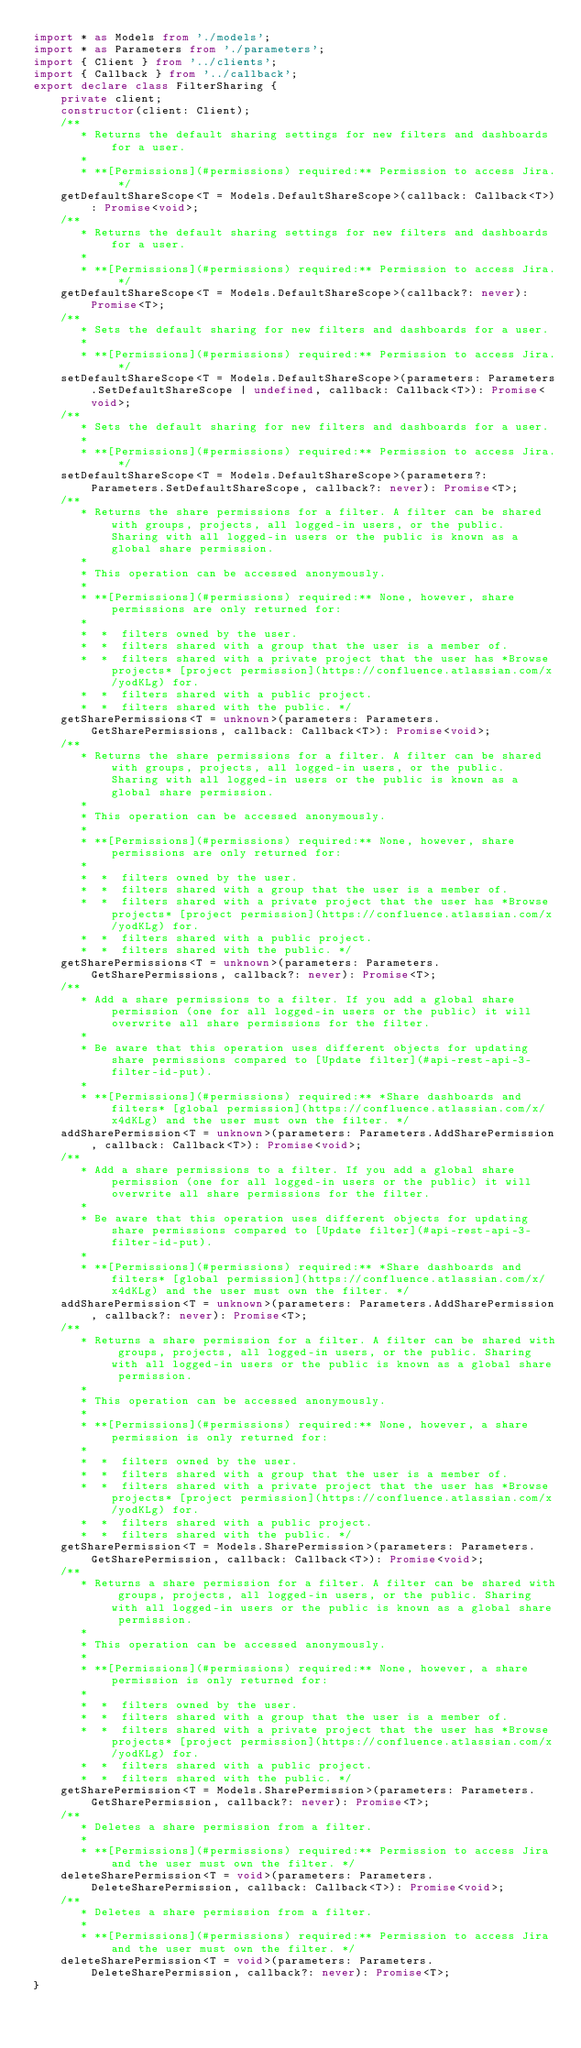<code> <loc_0><loc_0><loc_500><loc_500><_TypeScript_>import * as Models from './models';
import * as Parameters from './parameters';
import { Client } from '../clients';
import { Callback } from '../callback';
export declare class FilterSharing {
    private client;
    constructor(client: Client);
    /**
       * Returns the default sharing settings for new filters and dashboards for a user.
       *
       * **[Permissions](#permissions) required:** Permission to access Jira. */
    getDefaultShareScope<T = Models.DefaultShareScope>(callback: Callback<T>): Promise<void>;
    /**
       * Returns the default sharing settings for new filters and dashboards for a user.
       *
       * **[Permissions](#permissions) required:** Permission to access Jira. */
    getDefaultShareScope<T = Models.DefaultShareScope>(callback?: never): Promise<T>;
    /**
       * Sets the default sharing for new filters and dashboards for a user.
       *
       * **[Permissions](#permissions) required:** Permission to access Jira. */
    setDefaultShareScope<T = Models.DefaultShareScope>(parameters: Parameters.SetDefaultShareScope | undefined, callback: Callback<T>): Promise<void>;
    /**
       * Sets the default sharing for new filters and dashboards for a user.
       *
       * **[Permissions](#permissions) required:** Permission to access Jira. */
    setDefaultShareScope<T = Models.DefaultShareScope>(parameters?: Parameters.SetDefaultShareScope, callback?: never): Promise<T>;
    /**
       * Returns the share permissions for a filter. A filter can be shared with groups, projects, all logged-in users, or the public. Sharing with all logged-in users or the public is known as a global share permission.
       *
       * This operation can be accessed anonymously.
       *
       * **[Permissions](#permissions) required:** None, however, share permissions are only returned for:
       *
       *  *  filters owned by the user.
       *  *  filters shared with a group that the user is a member of.
       *  *  filters shared with a private project that the user has *Browse projects* [project permission](https://confluence.atlassian.com/x/yodKLg) for.
       *  *  filters shared with a public project.
       *  *  filters shared with the public. */
    getSharePermissions<T = unknown>(parameters: Parameters.GetSharePermissions, callback: Callback<T>): Promise<void>;
    /**
       * Returns the share permissions for a filter. A filter can be shared with groups, projects, all logged-in users, or the public. Sharing with all logged-in users or the public is known as a global share permission.
       *
       * This operation can be accessed anonymously.
       *
       * **[Permissions](#permissions) required:** None, however, share permissions are only returned for:
       *
       *  *  filters owned by the user.
       *  *  filters shared with a group that the user is a member of.
       *  *  filters shared with a private project that the user has *Browse projects* [project permission](https://confluence.atlassian.com/x/yodKLg) for.
       *  *  filters shared with a public project.
       *  *  filters shared with the public. */
    getSharePermissions<T = unknown>(parameters: Parameters.GetSharePermissions, callback?: never): Promise<T>;
    /**
       * Add a share permissions to a filter. If you add a global share permission (one for all logged-in users or the public) it will overwrite all share permissions for the filter.
       *
       * Be aware that this operation uses different objects for updating share permissions compared to [Update filter](#api-rest-api-3-filter-id-put).
       *
       * **[Permissions](#permissions) required:** *Share dashboards and filters* [global permission](https://confluence.atlassian.com/x/x4dKLg) and the user must own the filter. */
    addSharePermission<T = unknown>(parameters: Parameters.AddSharePermission, callback: Callback<T>): Promise<void>;
    /**
       * Add a share permissions to a filter. If you add a global share permission (one for all logged-in users or the public) it will overwrite all share permissions for the filter.
       *
       * Be aware that this operation uses different objects for updating share permissions compared to [Update filter](#api-rest-api-3-filter-id-put).
       *
       * **[Permissions](#permissions) required:** *Share dashboards and filters* [global permission](https://confluence.atlassian.com/x/x4dKLg) and the user must own the filter. */
    addSharePermission<T = unknown>(parameters: Parameters.AddSharePermission, callback?: never): Promise<T>;
    /**
       * Returns a share permission for a filter. A filter can be shared with groups, projects, all logged-in users, or the public. Sharing with all logged-in users or the public is known as a global share permission.
       *
       * This operation can be accessed anonymously.
       *
       * **[Permissions](#permissions) required:** None, however, a share permission is only returned for:
       *
       *  *  filters owned by the user.
       *  *  filters shared with a group that the user is a member of.
       *  *  filters shared with a private project that the user has *Browse projects* [project permission](https://confluence.atlassian.com/x/yodKLg) for.
       *  *  filters shared with a public project.
       *  *  filters shared with the public. */
    getSharePermission<T = Models.SharePermission>(parameters: Parameters.GetSharePermission, callback: Callback<T>): Promise<void>;
    /**
       * Returns a share permission for a filter. A filter can be shared with groups, projects, all logged-in users, or the public. Sharing with all logged-in users or the public is known as a global share permission.
       *
       * This operation can be accessed anonymously.
       *
       * **[Permissions](#permissions) required:** None, however, a share permission is only returned for:
       *
       *  *  filters owned by the user.
       *  *  filters shared with a group that the user is a member of.
       *  *  filters shared with a private project that the user has *Browse projects* [project permission](https://confluence.atlassian.com/x/yodKLg) for.
       *  *  filters shared with a public project.
       *  *  filters shared with the public. */
    getSharePermission<T = Models.SharePermission>(parameters: Parameters.GetSharePermission, callback?: never): Promise<T>;
    /**
       * Deletes a share permission from a filter.
       *
       * **[Permissions](#permissions) required:** Permission to access Jira and the user must own the filter. */
    deleteSharePermission<T = void>(parameters: Parameters.DeleteSharePermission, callback: Callback<T>): Promise<void>;
    /**
       * Deletes a share permission from a filter.
       *
       * **[Permissions](#permissions) required:** Permission to access Jira and the user must own the filter. */
    deleteSharePermission<T = void>(parameters: Parameters.DeleteSharePermission, callback?: never): Promise<T>;
}
</code> 